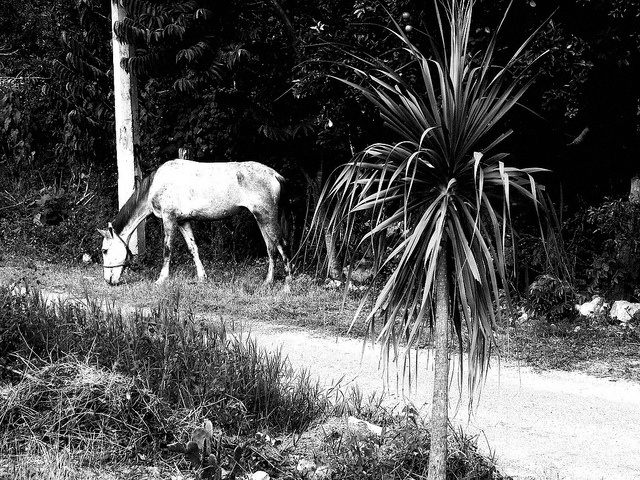Describe the objects in this image and their specific colors. I can see a horse in black, white, darkgray, and gray tones in this image. 